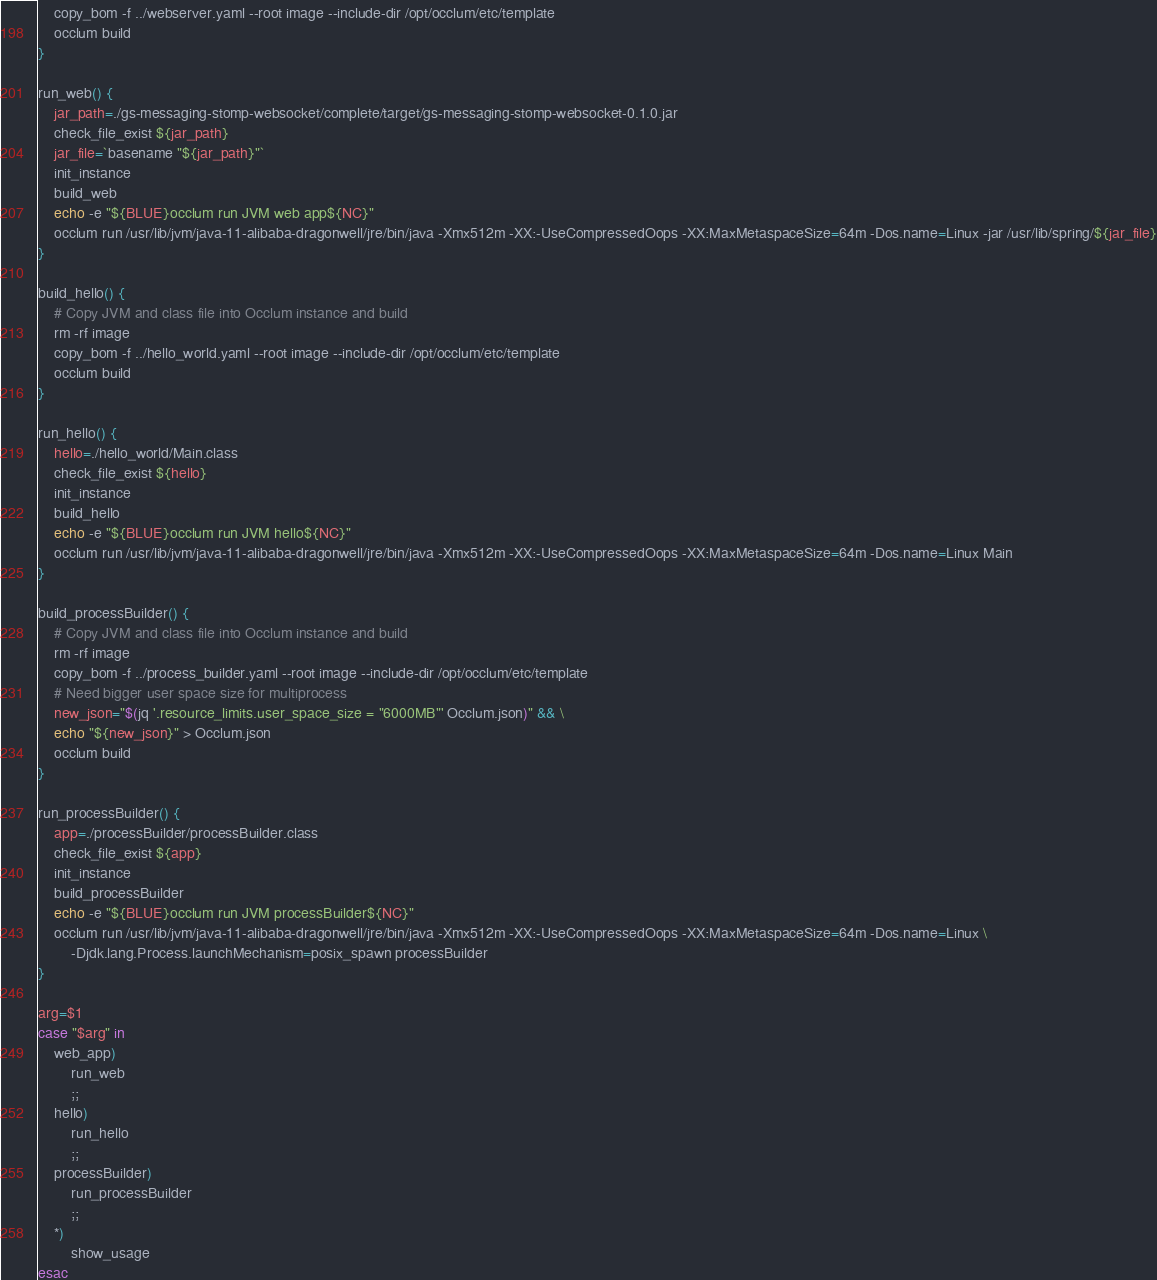<code> <loc_0><loc_0><loc_500><loc_500><_Bash_>    copy_bom -f ../webserver.yaml --root image --include-dir /opt/occlum/etc/template
    occlum build
}

run_web() {
    jar_path=./gs-messaging-stomp-websocket/complete/target/gs-messaging-stomp-websocket-0.1.0.jar
    check_file_exist ${jar_path}
    jar_file=`basename "${jar_path}"`
    init_instance
    build_web
    echo -e "${BLUE}occlum run JVM web app${NC}"
    occlum run /usr/lib/jvm/java-11-alibaba-dragonwell/jre/bin/java -Xmx512m -XX:-UseCompressedOops -XX:MaxMetaspaceSize=64m -Dos.name=Linux -jar /usr/lib/spring/${jar_file}
}

build_hello() {
    # Copy JVM and class file into Occlum instance and build
    rm -rf image
    copy_bom -f ../hello_world.yaml --root image --include-dir /opt/occlum/etc/template
    occlum build
}

run_hello() {
    hello=./hello_world/Main.class
    check_file_exist ${hello}
    init_instance
    build_hello
    echo -e "${BLUE}occlum run JVM hello${NC}"
    occlum run /usr/lib/jvm/java-11-alibaba-dragonwell/jre/bin/java -Xmx512m -XX:-UseCompressedOops -XX:MaxMetaspaceSize=64m -Dos.name=Linux Main
}

build_processBuilder() {
    # Copy JVM and class file into Occlum instance and build
    rm -rf image
    copy_bom -f ../process_builder.yaml --root image --include-dir /opt/occlum/etc/template
    # Need bigger user space size for multiprocess
    new_json="$(jq '.resource_limits.user_space_size = "6000MB"' Occlum.json)" && \
    echo "${new_json}" > Occlum.json
    occlum build
}

run_processBuilder() {
    app=./processBuilder/processBuilder.class
    check_file_exist ${app}
    init_instance
    build_processBuilder
    echo -e "${BLUE}occlum run JVM processBuilder${NC}"
    occlum run /usr/lib/jvm/java-11-alibaba-dragonwell/jre/bin/java -Xmx512m -XX:-UseCompressedOops -XX:MaxMetaspaceSize=64m -Dos.name=Linux \
        -Djdk.lang.Process.launchMechanism=posix_spawn processBuilder
}

arg=$1
case "$arg" in
    web_app)
        run_web
        ;;
    hello)
        run_hello
        ;;
    processBuilder)
        run_processBuilder
        ;;
    *)
        show_usage
esac
</code> 